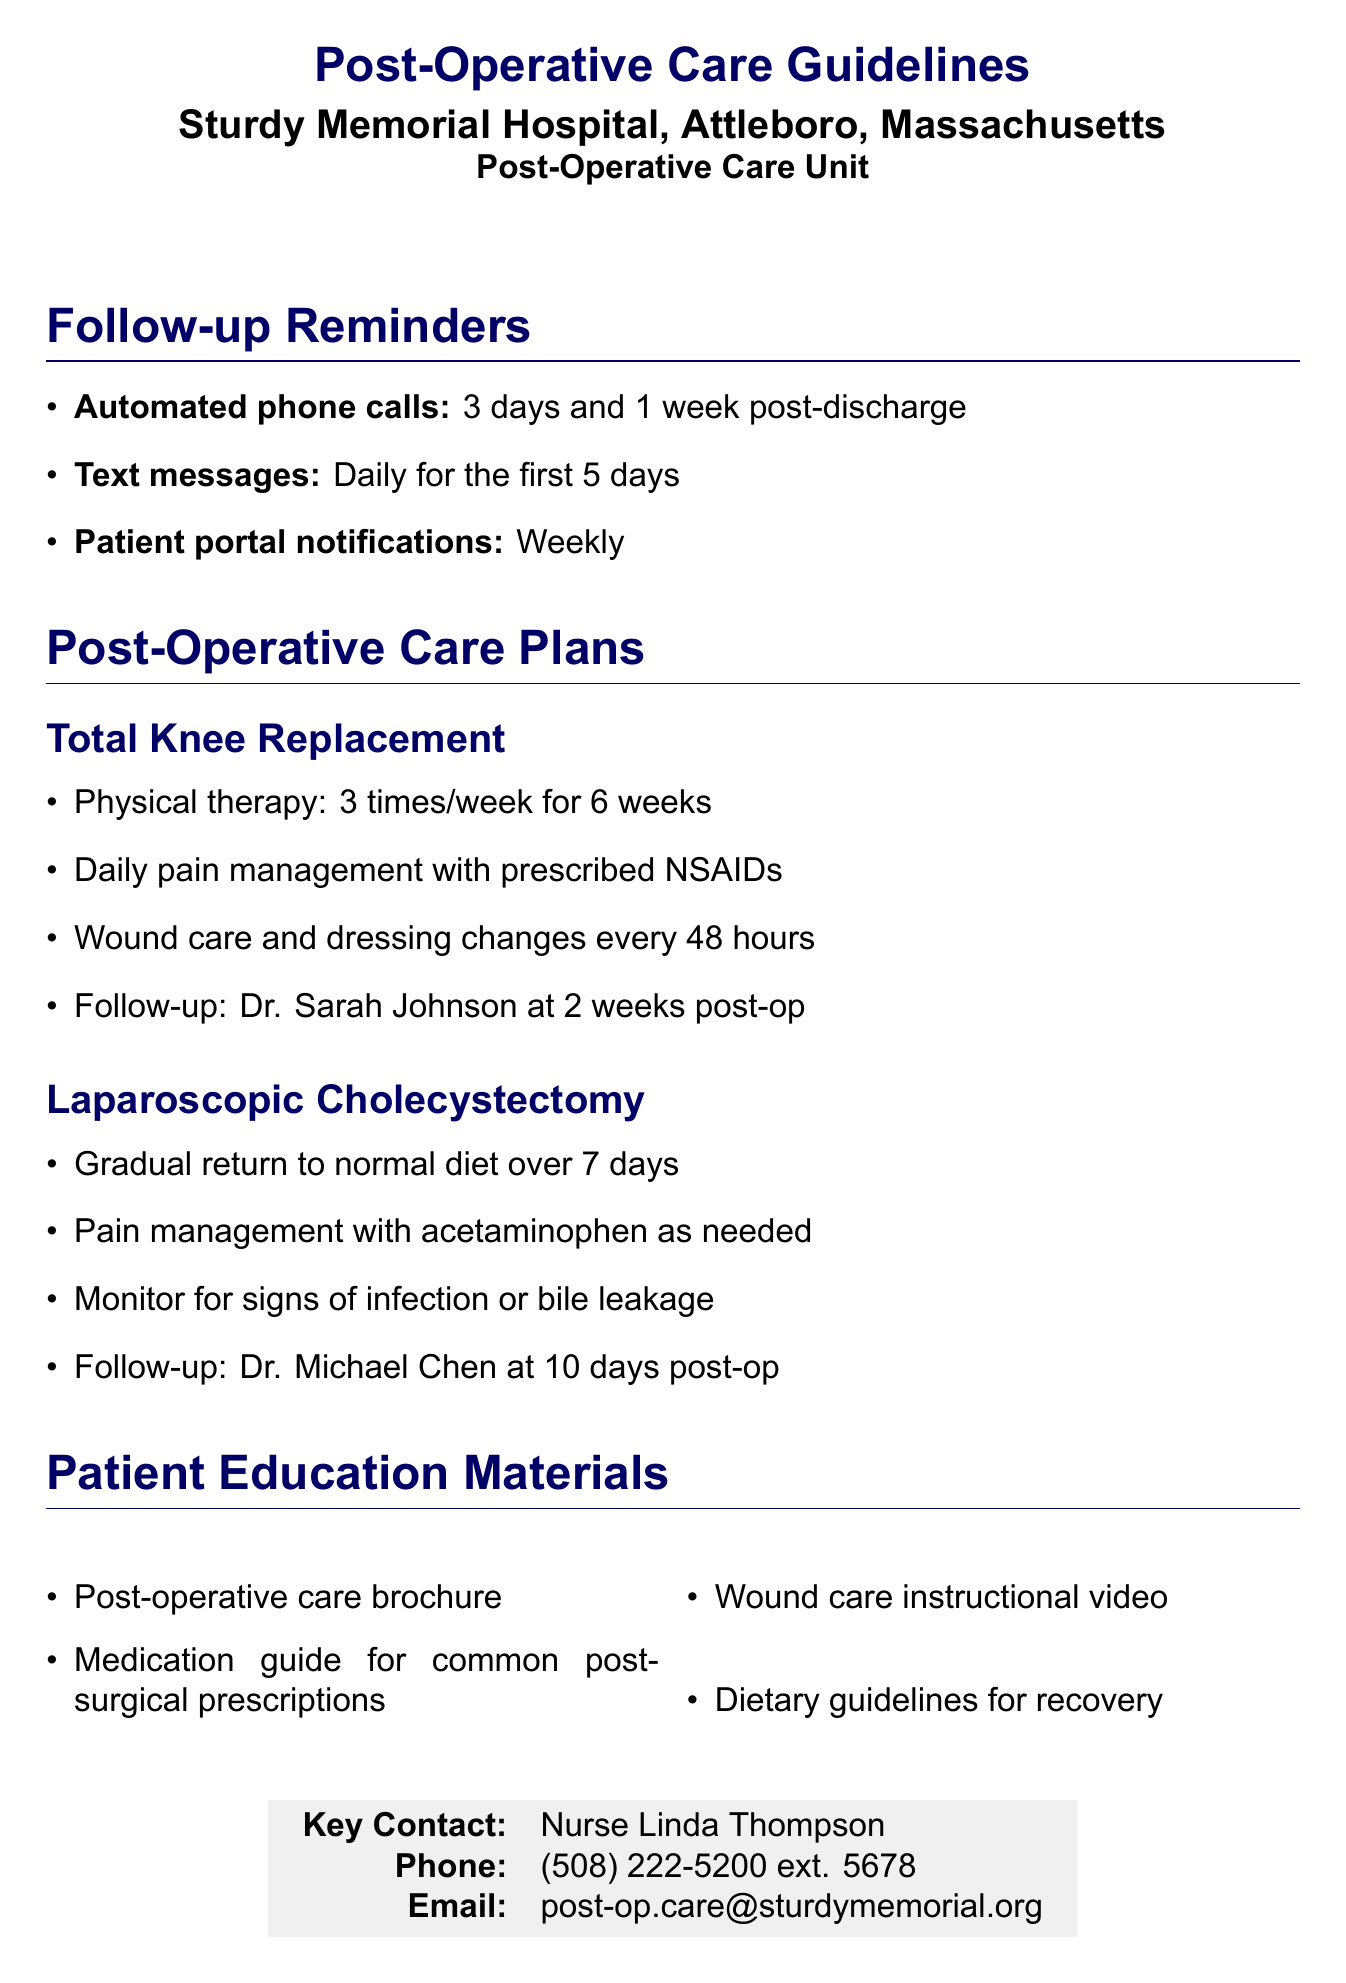What is the frequency of automated phone calls? The document states that automated phone calls occur 3 days and 1 week post-discharge.
Answer: 3 days and 1 week Who is the follow-up appointment for total knee replacement with? The document specifies the follow-up appointment with Dr. Sarah Johnson at 2 weeks post-op.
Answer: Dr. Sarah Johnson How many times a week should physical therapy sessions be conducted? The document indicates that physical therapy sessions should be conducted 3 times per week for 6 weeks.
Answer: 3 times What signs should be monitored after laparoscopic cholecystectomy? The document mentions monitoring for signs of infection or bile leakage.
Answer: Infection or bile leakage What type of material is included for patient education? The document lists various educational materials, including a post-operative care brochure.
Answer: Post-operative care brochure 